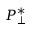Convert formula to latex. <formula><loc_0><loc_0><loc_500><loc_500>P _ { \perp } ^ { * }</formula> 